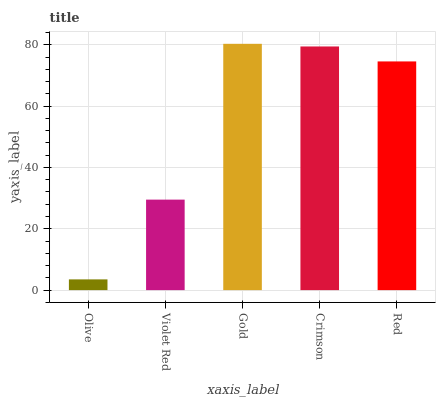Is Olive the minimum?
Answer yes or no. Yes. Is Gold the maximum?
Answer yes or no. Yes. Is Violet Red the minimum?
Answer yes or no. No. Is Violet Red the maximum?
Answer yes or no. No. Is Violet Red greater than Olive?
Answer yes or no. Yes. Is Olive less than Violet Red?
Answer yes or no. Yes. Is Olive greater than Violet Red?
Answer yes or no. No. Is Violet Red less than Olive?
Answer yes or no. No. Is Red the high median?
Answer yes or no. Yes. Is Red the low median?
Answer yes or no. Yes. Is Gold the high median?
Answer yes or no. No. Is Crimson the low median?
Answer yes or no. No. 